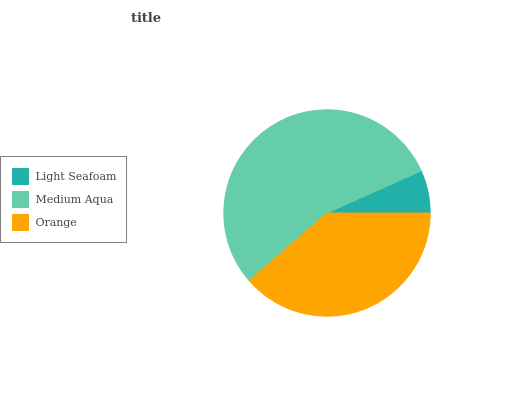Is Light Seafoam the minimum?
Answer yes or no. Yes. Is Medium Aqua the maximum?
Answer yes or no. Yes. Is Orange the minimum?
Answer yes or no. No. Is Orange the maximum?
Answer yes or no. No. Is Medium Aqua greater than Orange?
Answer yes or no. Yes. Is Orange less than Medium Aqua?
Answer yes or no. Yes. Is Orange greater than Medium Aqua?
Answer yes or no. No. Is Medium Aqua less than Orange?
Answer yes or no. No. Is Orange the high median?
Answer yes or no. Yes. Is Orange the low median?
Answer yes or no. Yes. Is Medium Aqua the high median?
Answer yes or no. No. Is Light Seafoam the low median?
Answer yes or no. No. 